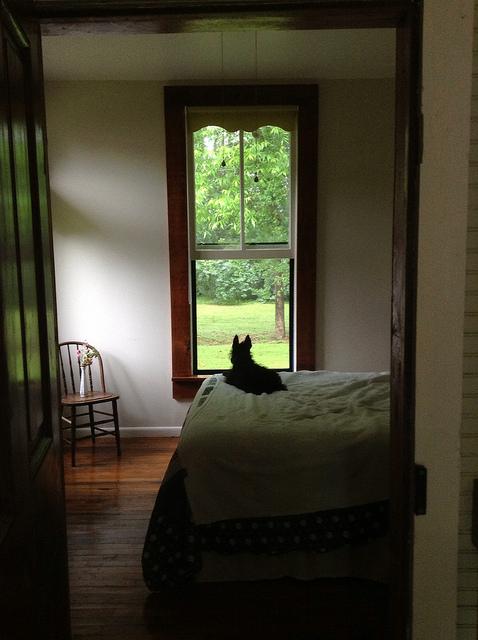What is outside the window?
Be succinct. Tree. Is there a backpack in this picture?
Quick response, please. No. How many animals are in this picture?
Answer briefly. 1. What is on the corners of the bed?
Give a very brief answer. Dog. What is on the bed in the back?
Answer briefly. Dog. Where is the cat in the photo?
Keep it brief. On bed. What animal is this?
Answer briefly. Dog. Are there any mirrors?
Short answer required. No. How many people can sleep in here?
Quick response, please. 2. What is resting next to the bed near the dresser?
Short answer required. Dog. What is the cat sleeping on?
Write a very short answer. Bed. What season of the year is it?
Concise answer only. Summer. What is on the bed?
Be succinct. Dog. Is there an animal in the scene?
Short answer required. Yes. Is there a lamp on in the room?
Be succinct. No. Is there something unusual surrounding the bed?
Keep it brief. No. Is there good ambient lighting in the room?
Write a very short answer. No. Is the bed made?
Concise answer only. Yes. How many pets?
Be succinct. 1. Is that a cat on the bed?
Keep it brief. No. What color is the window frame?
Short answer required. Brown. What is this style of bed called?
Write a very short answer. Queen. What room is this?
Short answer required. Bedroom. What kind of pet is in the picture?
Short answer required. Dog. Is it dark outside?
Write a very short answer. No. Is the curtain closed?
Give a very brief answer. No. What is sitting on the bed?
Write a very short answer. Dog. Are there screens in the windows?
Answer briefly. Yes. Are there blinds in this picture?
Give a very brief answer. No. Can the dog get out the window at the moment?
Quick response, please. No. Is the wall clean?
Give a very brief answer. Yes. Is the ceiling in this room tall?
Be succinct. Yes. How large is the bed?
Short answer required. Queen. Does the bed have curtains?
Concise answer only. No. 